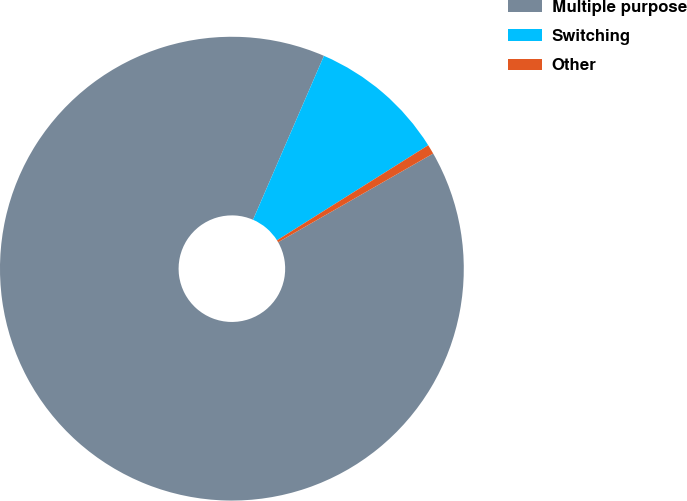Convert chart. <chart><loc_0><loc_0><loc_500><loc_500><pie_chart><fcel>Multiple purpose<fcel>Switching<fcel>Other<nl><fcel>89.77%<fcel>9.57%<fcel>0.66%<nl></chart> 